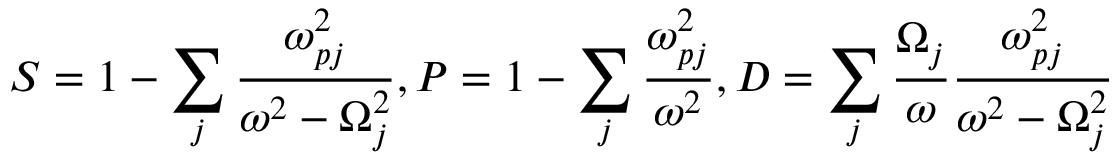Convert formula to latex. <formula><loc_0><loc_0><loc_500><loc_500>S = 1 - \sum _ { j } \frac { \omega _ { p j } ^ { 2 } } { \omega ^ { 2 } - \Omega _ { j } ^ { 2 } } , P = 1 - \sum _ { j } \frac { \omega _ { p j } ^ { 2 } } { \omega ^ { 2 } } , D = \sum _ { j } \frac { \Omega _ { j } } { \omega } \frac { \omega _ { p j } ^ { 2 } } { \omega ^ { 2 } - \Omega _ { j } ^ { 2 } }</formula> 